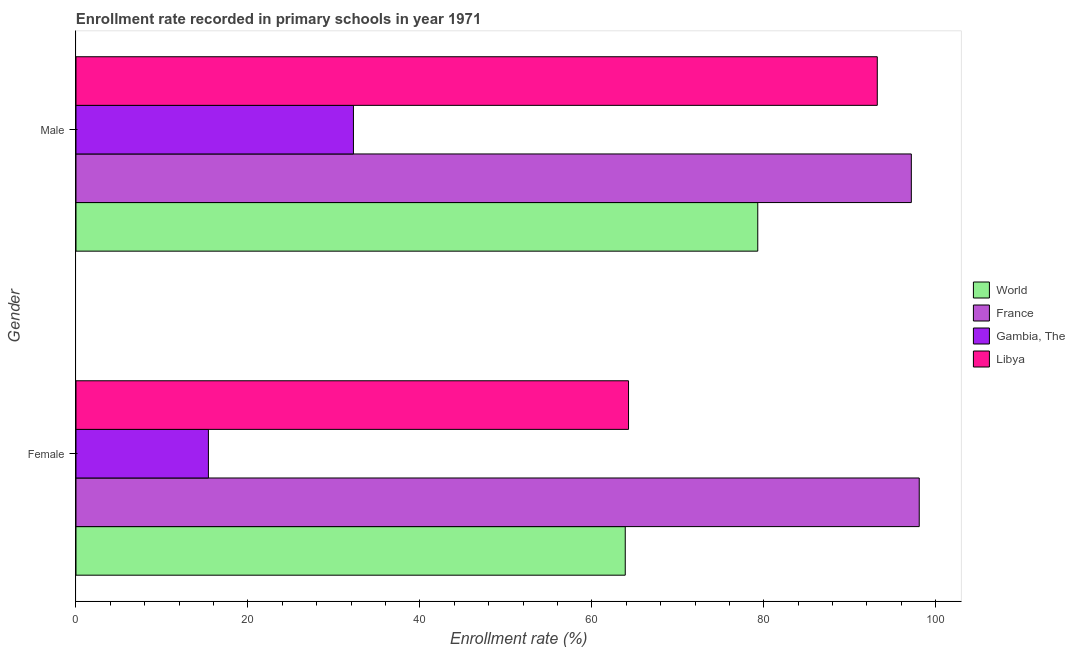Are the number of bars per tick equal to the number of legend labels?
Keep it short and to the point. Yes. What is the enrollment rate of female students in Libya?
Make the answer very short. 64.27. Across all countries, what is the maximum enrollment rate of male students?
Offer a very short reply. 97.16. Across all countries, what is the minimum enrollment rate of female students?
Provide a short and direct response. 15.4. In which country was the enrollment rate of female students minimum?
Keep it short and to the point. Gambia, The. What is the total enrollment rate of male students in the graph?
Your answer should be compact. 301.94. What is the difference between the enrollment rate of male students in Libya and that in World?
Your answer should be compact. 13.9. What is the difference between the enrollment rate of male students in Gambia, The and the enrollment rate of female students in World?
Your answer should be compact. -31.62. What is the average enrollment rate of male students per country?
Keep it short and to the point. 75.48. What is the difference between the enrollment rate of male students and enrollment rate of female students in World?
Provide a short and direct response. 15.41. What is the ratio of the enrollment rate of male students in Gambia, The to that in World?
Give a very brief answer. 0.41. Is the enrollment rate of female students in Gambia, The less than that in France?
Provide a succinct answer. Yes. What does the 2nd bar from the top in Male represents?
Provide a short and direct response. Gambia, The. What does the 3rd bar from the bottom in Female represents?
Your answer should be compact. Gambia, The. Are all the bars in the graph horizontal?
Keep it short and to the point. Yes. What is the difference between two consecutive major ticks on the X-axis?
Keep it short and to the point. 20. Are the values on the major ticks of X-axis written in scientific E-notation?
Make the answer very short. No. Does the graph contain grids?
Your response must be concise. No. Where does the legend appear in the graph?
Provide a short and direct response. Center right. What is the title of the graph?
Provide a short and direct response. Enrollment rate recorded in primary schools in year 1971. What is the label or title of the X-axis?
Provide a succinct answer. Enrollment rate (%). What is the label or title of the Y-axis?
Keep it short and to the point. Gender. What is the Enrollment rate (%) in World in Female?
Offer a very short reply. 63.89. What is the Enrollment rate (%) in France in Female?
Offer a very short reply. 98.08. What is the Enrollment rate (%) of Gambia, The in Female?
Your answer should be very brief. 15.4. What is the Enrollment rate (%) of Libya in Female?
Offer a terse response. 64.27. What is the Enrollment rate (%) in World in Male?
Offer a terse response. 79.3. What is the Enrollment rate (%) of France in Male?
Offer a very short reply. 97.16. What is the Enrollment rate (%) of Gambia, The in Male?
Your response must be concise. 32.27. What is the Enrollment rate (%) in Libya in Male?
Make the answer very short. 93.2. Across all Gender, what is the maximum Enrollment rate (%) of World?
Provide a short and direct response. 79.3. Across all Gender, what is the maximum Enrollment rate (%) of France?
Your answer should be compact. 98.08. Across all Gender, what is the maximum Enrollment rate (%) of Gambia, The?
Your answer should be very brief. 32.27. Across all Gender, what is the maximum Enrollment rate (%) in Libya?
Your answer should be very brief. 93.2. Across all Gender, what is the minimum Enrollment rate (%) of World?
Provide a short and direct response. 63.89. Across all Gender, what is the minimum Enrollment rate (%) of France?
Provide a short and direct response. 97.16. Across all Gender, what is the minimum Enrollment rate (%) of Gambia, The?
Offer a terse response. 15.4. Across all Gender, what is the minimum Enrollment rate (%) of Libya?
Offer a terse response. 64.27. What is the total Enrollment rate (%) in World in the graph?
Provide a succinct answer. 143.19. What is the total Enrollment rate (%) of France in the graph?
Provide a short and direct response. 195.25. What is the total Enrollment rate (%) of Gambia, The in the graph?
Keep it short and to the point. 47.67. What is the total Enrollment rate (%) in Libya in the graph?
Your response must be concise. 157.47. What is the difference between the Enrollment rate (%) of World in Female and that in Male?
Offer a very short reply. -15.41. What is the difference between the Enrollment rate (%) in France in Female and that in Male?
Ensure brevity in your answer.  0.92. What is the difference between the Enrollment rate (%) in Gambia, The in Female and that in Male?
Offer a terse response. -16.87. What is the difference between the Enrollment rate (%) in Libya in Female and that in Male?
Ensure brevity in your answer.  -28.93. What is the difference between the Enrollment rate (%) of World in Female and the Enrollment rate (%) of France in Male?
Keep it short and to the point. -33.28. What is the difference between the Enrollment rate (%) of World in Female and the Enrollment rate (%) of Gambia, The in Male?
Your answer should be very brief. 31.62. What is the difference between the Enrollment rate (%) of World in Female and the Enrollment rate (%) of Libya in Male?
Offer a terse response. -29.32. What is the difference between the Enrollment rate (%) of France in Female and the Enrollment rate (%) of Gambia, The in Male?
Keep it short and to the point. 65.81. What is the difference between the Enrollment rate (%) of France in Female and the Enrollment rate (%) of Libya in Male?
Offer a very short reply. 4.88. What is the difference between the Enrollment rate (%) in Gambia, The in Female and the Enrollment rate (%) in Libya in Male?
Provide a succinct answer. -77.8. What is the average Enrollment rate (%) of World per Gender?
Offer a terse response. 71.59. What is the average Enrollment rate (%) of France per Gender?
Offer a terse response. 97.62. What is the average Enrollment rate (%) of Gambia, The per Gender?
Your response must be concise. 23.84. What is the average Enrollment rate (%) of Libya per Gender?
Give a very brief answer. 78.74. What is the difference between the Enrollment rate (%) of World and Enrollment rate (%) of France in Female?
Your answer should be compact. -34.2. What is the difference between the Enrollment rate (%) in World and Enrollment rate (%) in Gambia, The in Female?
Offer a terse response. 48.48. What is the difference between the Enrollment rate (%) of World and Enrollment rate (%) of Libya in Female?
Ensure brevity in your answer.  -0.38. What is the difference between the Enrollment rate (%) of France and Enrollment rate (%) of Gambia, The in Female?
Your response must be concise. 82.68. What is the difference between the Enrollment rate (%) in France and Enrollment rate (%) in Libya in Female?
Offer a terse response. 33.81. What is the difference between the Enrollment rate (%) of Gambia, The and Enrollment rate (%) of Libya in Female?
Provide a succinct answer. -48.87. What is the difference between the Enrollment rate (%) of World and Enrollment rate (%) of France in Male?
Your answer should be very brief. -17.86. What is the difference between the Enrollment rate (%) in World and Enrollment rate (%) in Gambia, The in Male?
Your answer should be very brief. 47.03. What is the difference between the Enrollment rate (%) in World and Enrollment rate (%) in Libya in Male?
Provide a succinct answer. -13.9. What is the difference between the Enrollment rate (%) of France and Enrollment rate (%) of Gambia, The in Male?
Provide a succinct answer. 64.89. What is the difference between the Enrollment rate (%) of France and Enrollment rate (%) of Libya in Male?
Ensure brevity in your answer.  3.96. What is the difference between the Enrollment rate (%) of Gambia, The and Enrollment rate (%) of Libya in Male?
Your answer should be very brief. -60.93. What is the ratio of the Enrollment rate (%) of World in Female to that in Male?
Your answer should be very brief. 0.81. What is the ratio of the Enrollment rate (%) of France in Female to that in Male?
Give a very brief answer. 1.01. What is the ratio of the Enrollment rate (%) in Gambia, The in Female to that in Male?
Ensure brevity in your answer.  0.48. What is the ratio of the Enrollment rate (%) in Libya in Female to that in Male?
Provide a succinct answer. 0.69. What is the difference between the highest and the second highest Enrollment rate (%) of World?
Your answer should be very brief. 15.41. What is the difference between the highest and the second highest Enrollment rate (%) in France?
Your response must be concise. 0.92. What is the difference between the highest and the second highest Enrollment rate (%) of Gambia, The?
Offer a terse response. 16.87. What is the difference between the highest and the second highest Enrollment rate (%) in Libya?
Provide a short and direct response. 28.93. What is the difference between the highest and the lowest Enrollment rate (%) of World?
Give a very brief answer. 15.41. What is the difference between the highest and the lowest Enrollment rate (%) of France?
Give a very brief answer. 0.92. What is the difference between the highest and the lowest Enrollment rate (%) of Gambia, The?
Your answer should be very brief. 16.87. What is the difference between the highest and the lowest Enrollment rate (%) of Libya?
Your response must be concise. 28.93. 